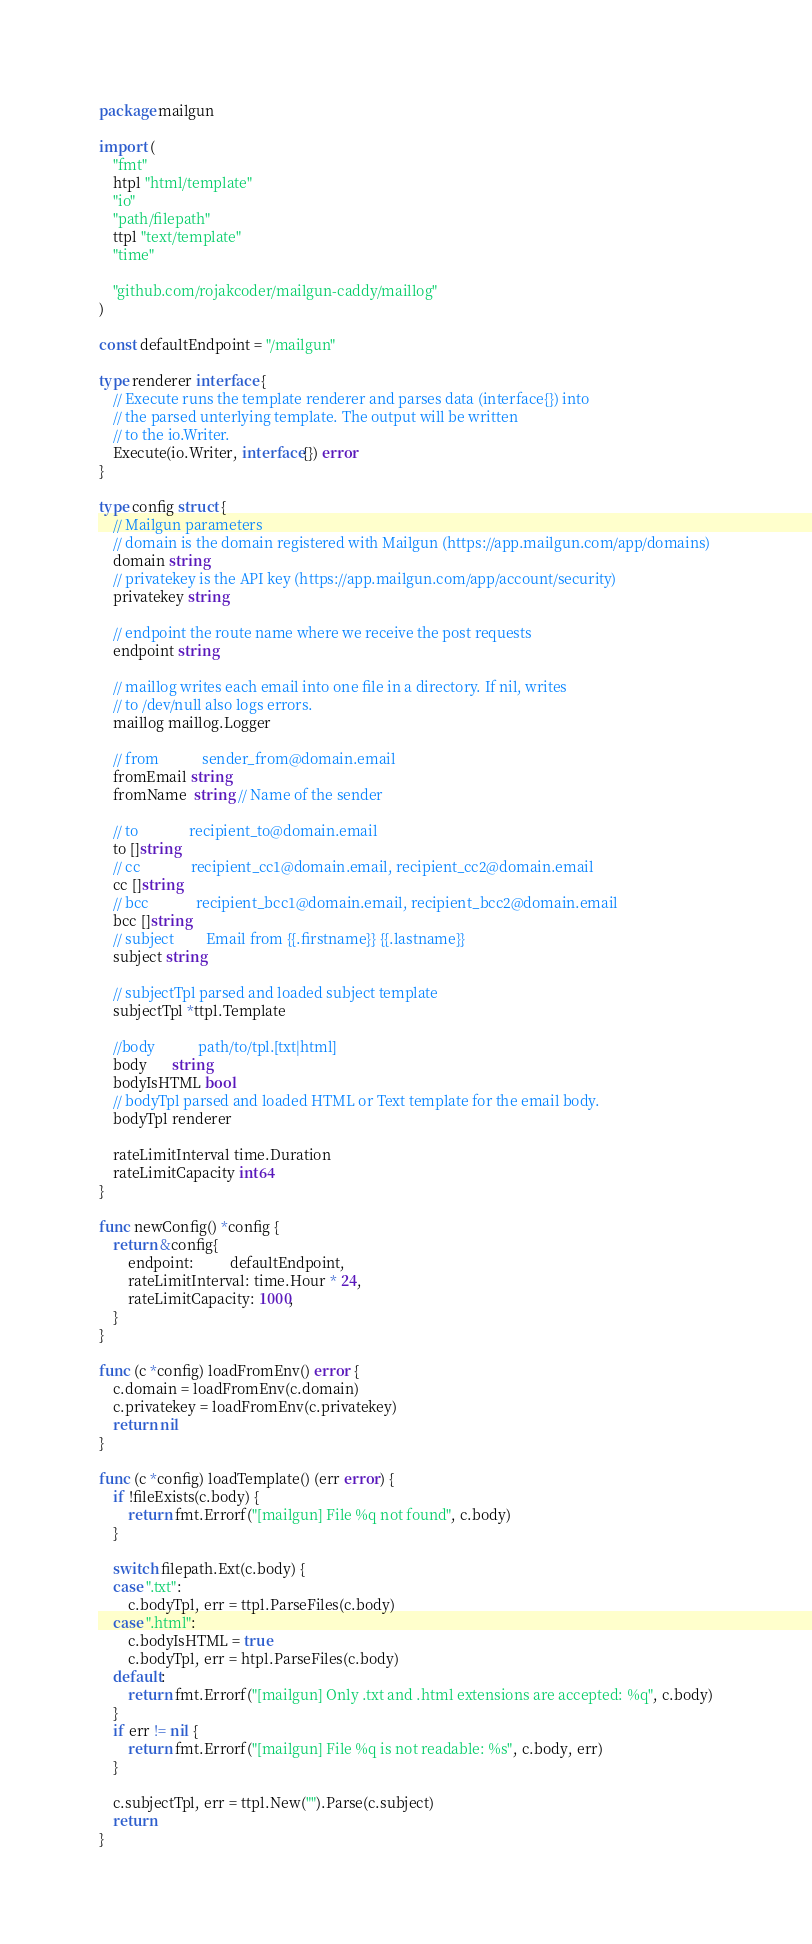<code> <loc_0><loc_0><loc_500><loc_500><_Go_>package mailgun

import (
	"fmt"
	htpl "html/template"
	"io"
	"path/filepath"
	ttpl "text/template"
	"time"

	"github.com/rojakcoder/mailgun-caddy/maillog"
)

const defaultEndpoint = "/mailgun"

type renderer interface {
	// Execute runs the template renderer and parses data (interface{}) into
	// the parsed unterlying template. The output will be written
	// to the io.Writer.
	Execute(io.Writer, interface{}) error
}

type config struct {
	// Mailgun parameters
	// domain is the domain registered with Mailgun (https://app.mailgun.com/app/domains)
	domain string
	// privatekey is the API key (https://app.mailgun.com/app/account/security)
	privatekey string

	// endpoint the route name where we receive the post requests
	endpoint string

	// maillog writes each email into one file in a directory. If nil, writes
	// to /dev/null also logs errors.
	maillog maillog.Logger

	// from            sender_from@domain.email
	fromEmail string
	fromName  string // Name of the sender

	// to              recipient_to@domain.email
	to []string
	// cc              recipient_cc1@domain.email, recipient_cc2@domain.email
	cc []string
	// bcc             recipient_bcc1@domain.email, recipient_bcc2@domain.email
	bcc []string
	// subject         Email from {{.firstname}} {{.lastname}}
	subject string

	// subjectTpl parsed and loaded subject template
	subjectTpl *ttpl.Template

	//body            path/to/tpl.[txt|html]
	body       string
	bodyIsHTML bool
	// bodyTpl parsed and loaded HTML or Text template for the email body.
	bodyTpl renderer

	rateLimitInterval time.Duration
	rateLimitCapacity int64
}

func newConfig() *config {
	return &config{
		endpoint:          defaultEndpoint,
		rateLimitInterval: time.Hour * 24,
		rateLimitCapacity: 1000,
	}
}

func (c *config) loadFromEnv() error {
	c.domain = loadFromEnv(c.domain)
	c.privatekey = loadFromEnv(c.privatekey)
	return nil
}

func (c *config) loadTemplate() (err error) {
	if !fileExists(c.body) {
		return fmt.Errorf("[mailgun] File %q not found", c.body)
	}

	switch filepath.Ext(c.body) {
	case ".txt":
		c.bodyTpl, err = ttpl.ParseFiles(c.body)
	case ".html":
		c.bodyIsHTML = true
		c.bodyTpl, err = htpl.ParseFiles(c.body)
	default:
		return fmt.Errorf("[mailgun] Only .txt and .html extensions are accepted: %q", c.body)
	}
	if err != nil {
		return fmt.Errorf("[mailgun] File %q is not readable: %s", c.body, err)
	}

	c.subjectTpl, err = ttpl.New("").Parse(c.subject)
	return
}
</code> 